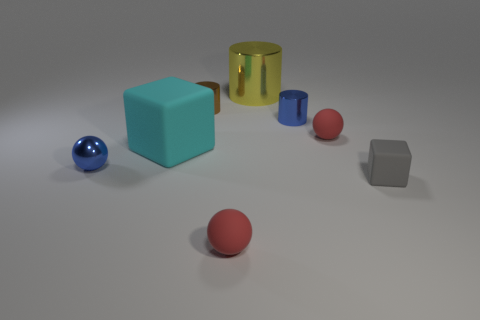Is there anything else that is the same color as the big metallic cylinder?
Provide a short and direct response. No. There is a matte thing that is on the left side of the big cylinder and behind the small blue metal ball; how big is it?
Your answer should be very brief. Large. How many objects are small red balls or tiny metal things?
Keep it short and to the point. 5. Is the size of the blue shiny cylinder the same as the yellow cylinder that is behind the large cyan rubber block?
Ensure brevity in your answer.  No. There is a block to the left of the ball that is to the right of the tiny red matte sphere to the left of the large metallic thing; what size is it?
Provide a short and direct response. Large. Are any small blue things visible?
Ensure brevity in your answer.  Yes. There is a small object that is the same color as the metal sphere; what is it made of?
Keep it short and to the point. Metal. What number of small objects have the same color as the metallic sphere?
Offer a very short reply. 1. What number of things are either blue objects on the right side of the small brown thing or spheres that are to the right of the small brown object?
Provide a succinct answer. 3. How many tiny blue cylinders are left of the tiny blue metal object right of the small blue shiny sphere?
Ensure brevity in your answer.  0. 